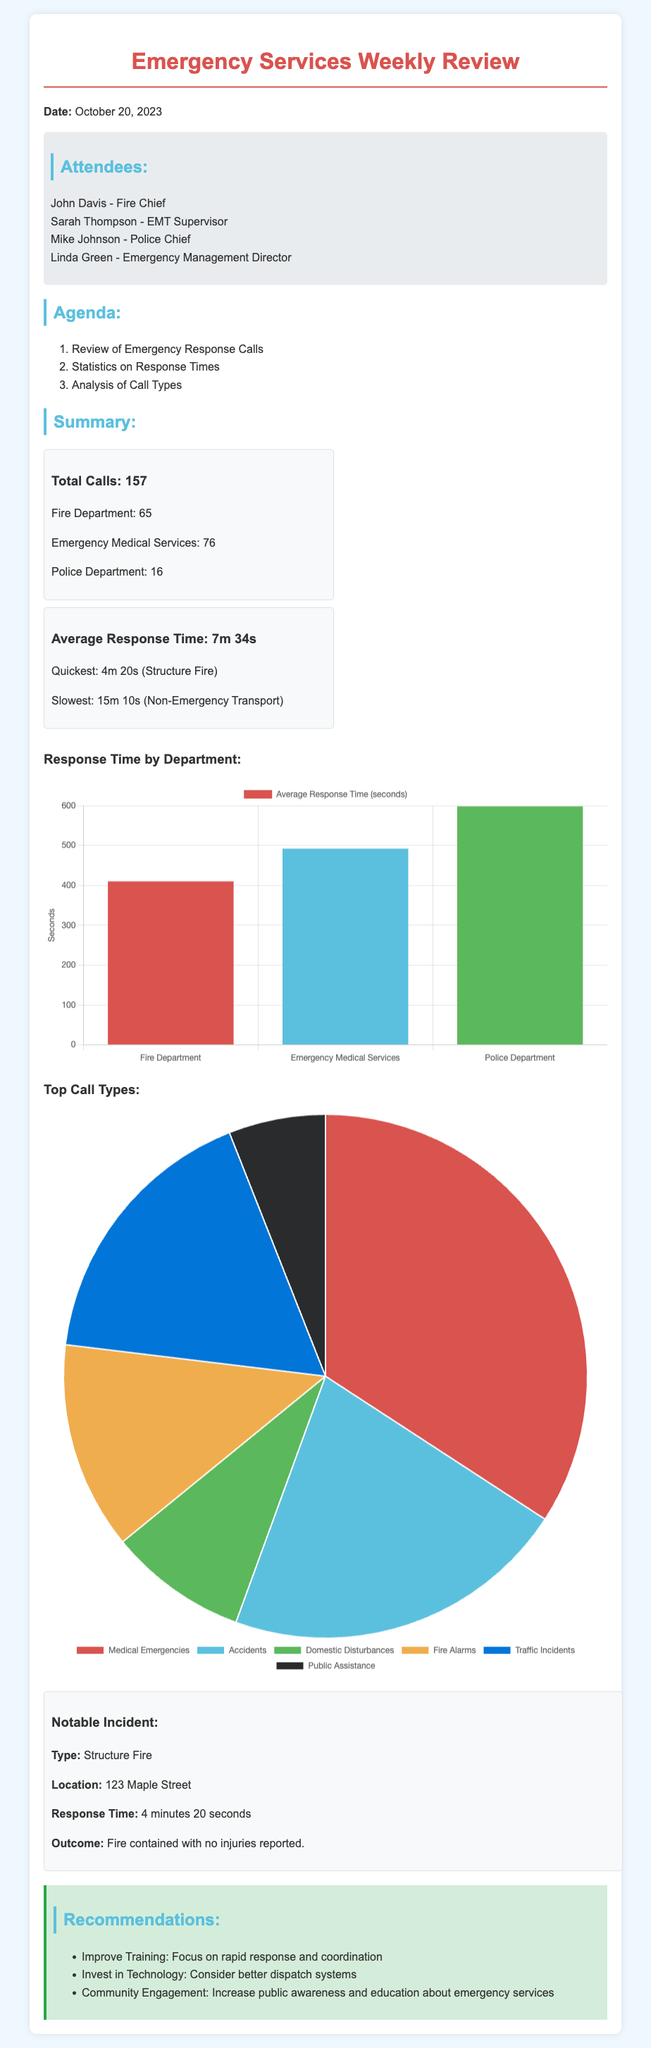What is the date of the meeting? The date of the meeting is mentioned at the beginning of the document.
Answer: October 20, 2023 How many total calls were made? The total calls are provided in the summary section of the document.
Answer: 157 What was the quickest response time recorded? The quickest response time is specified in the statistics section.
Answer: 4m 20s Which department had the highest number of calls? The number of calls by department is detailed in the summary section.
Answer: Emergency Medical Services What percentage of calls were classified as Medical Emergencies? The call types statistics provide the breakdown, which can be used to calculate the percentage.
Answer: 40% What was the outcome of the notable incident? The outcome of the notable incident is described in the summary of that incident.
Answer: Fire contained with no injuries reported How many attendees were present at the meeting? The attendees are listed in a section dedicated to that topic in the document.
Answer: 4 What is one of the recommendations made in the meeting? The recommendations are listed in a section specifically for recommendations.
Answer: Improve Training: Focus on rapid response and coordination What is the average response time reported? The average response time is mentioned in the statistics section of the document.
Answer: 7m 34s 